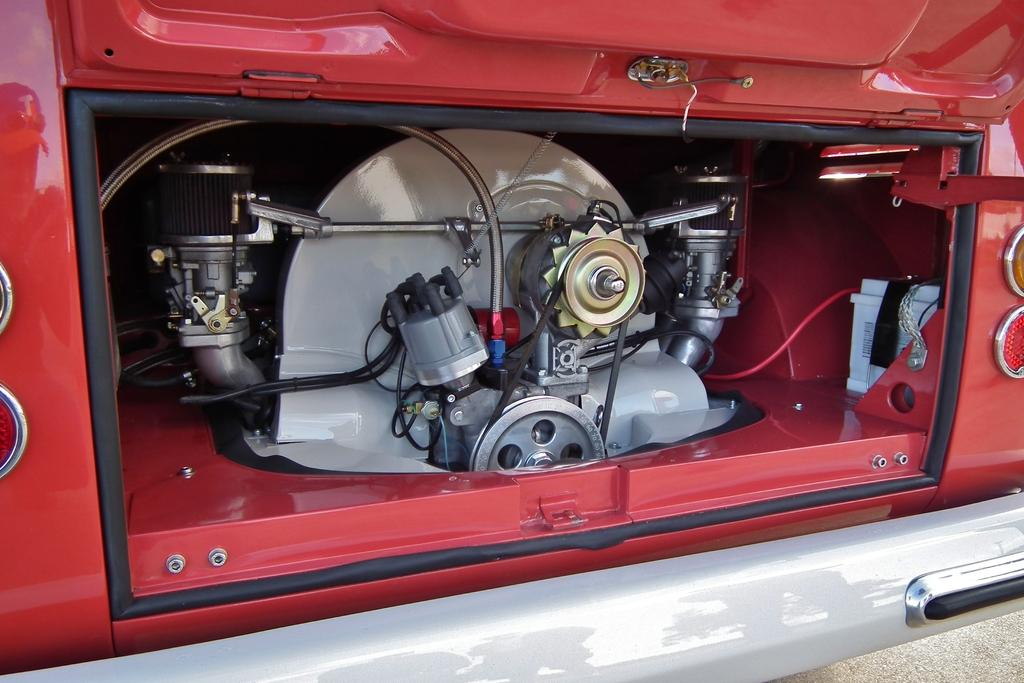What type of vehicle is shown in the image? The image shows a back view of a vehicle. What can be seen on the vehicle? There are lights visible on the vehicle. What powers the vehicle? There is an engine associated with the vehicle. What is the setting of the image? There is a road at the bottom of the image. What type of patch is being protested by the machine in the image? There is no patch or protest present in the image; it shows a back view of a vehicle with lights and an engine, and a road in the background. 